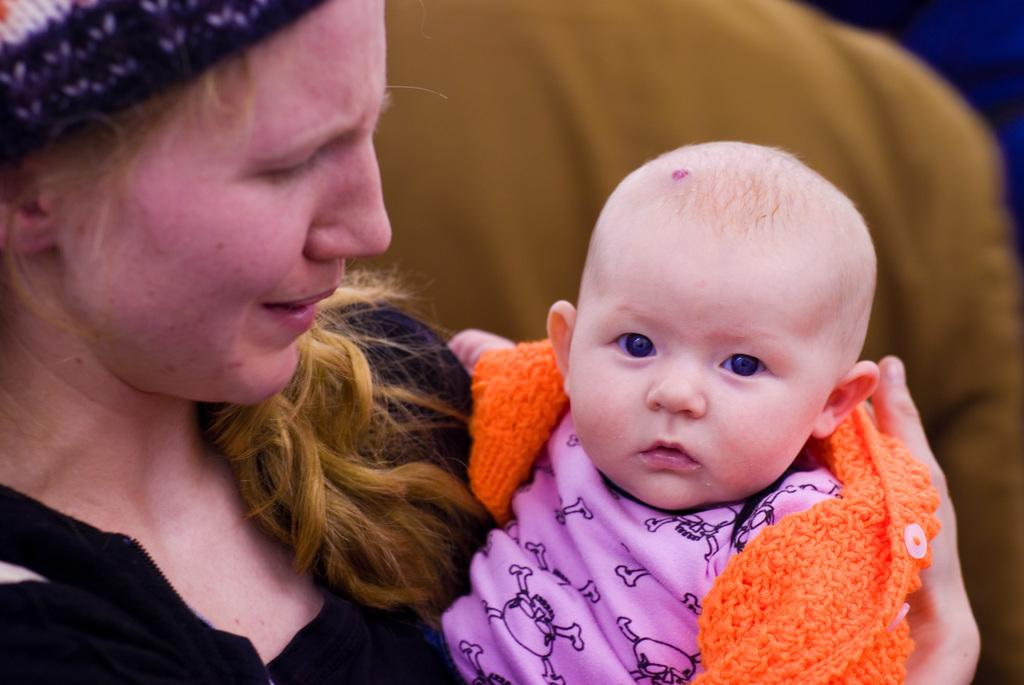Who is present in the image? There is a woman and a baby in the image. Where are the woman and baby located in the image? The woman and baby are in the middle of the picture. What can be observed about the background of the image? The background of the image is blurred. What type of shock can be seen affecting the baby in the image? There is no shock present in the image; the baby appears to be calm and content. How many crows are visible in the image? There are no crows present in the image. 